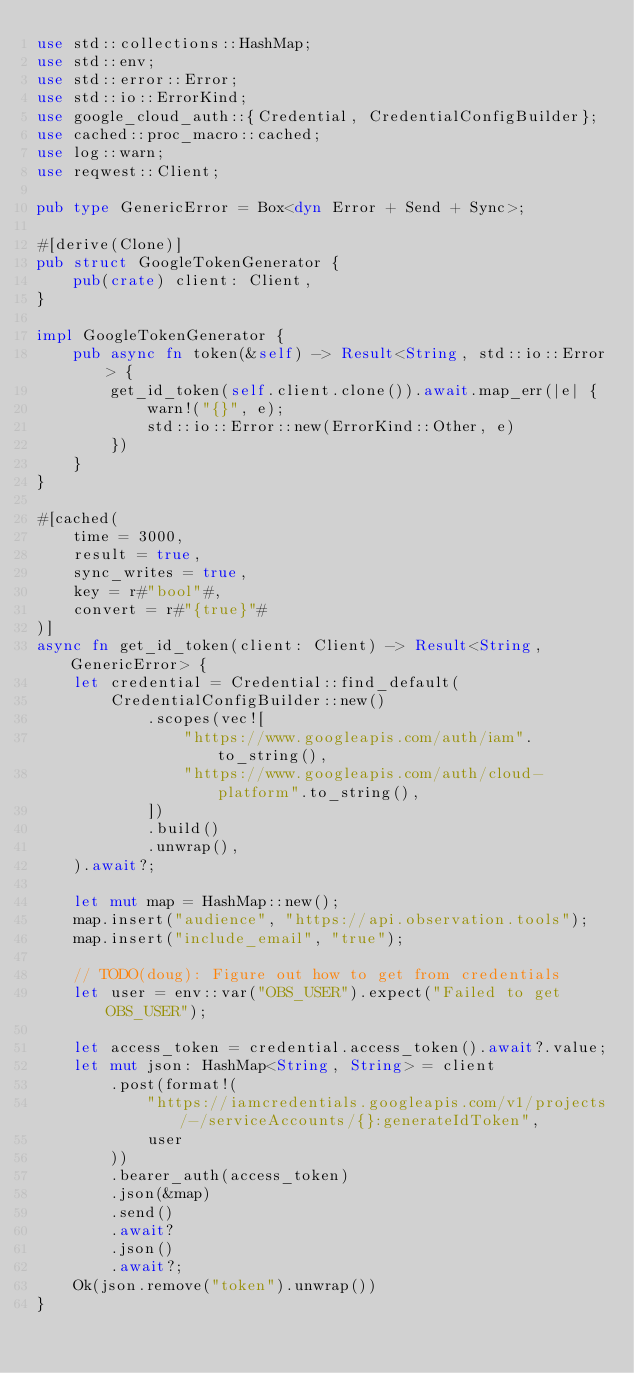Convert code to text. <code><loc_0><loc_0><loc_500><loc_500><_Rust_>use std::collections::HashMap;
use std::env;
use std::error::Error;
use std::io::ErrorKind;
use google_cloud_auth::{Credential, CredentialConfigBuilder};
use cached::proc_macro::cached;
use log::warn;
use reqwest::Client;

pub type GenericError = Box<dyn Error + Send + Sync>;

#[derive(Clone)]
pub struct GoogleTokenGenerator {
    pub(crate) client: Client,
}

impl GoogleTokenGenerator {
    pub async fn token(&self) -> Result<String, std::io::Error> {
        get_id_token(self.client.clone()).await.map_err(|e| {
            warn!("{}", e);
            std::io::Error::new(ErrorKind::Other, e)
        })
    }
}

#[cached(
    time = 3000,
    result = true,
    sync_writes = true,
    key = r#"bool"#,
    convert = r#"{true}"#
)]
async fn get_id_token(client: Client) -> Result<String, GenericError> {
    let credential = Credential::find_default(
        CredentialConfigBuilder::new()
            .scopes(vec![
                "https://www.googleapis.com/auth/iam".to_string(),
                "https://www.googleapis.com/auth/cloud-platform".to_string(),
            ])
            .build()
            .unwrap(),
    ).await?;

    let mut map = HashMap::new();
    map.insert("audience", "https://api.observation.tools");
    map.insert("include_email", "true");

    // TODO(doug): Figure out how to get from credentials
    let user = env::var("OBS_USER").expect("Failed to get OBS_USER");

    let access_token = credential.access_token().await?.value;
    let mut json: HashMap<String, String> = client
        .post(format!(
            "https://iamcredentials.googleapis.com/v1/projects/-/serviceAccounts/{}:generateIdToken",
            user
        ))
        .bearer_auth(access_token)
        .json(&map)
        .send()
        .await?
        .json()
        .await?;
    Ok(json.remove("token").unwrap())
}

</code> 